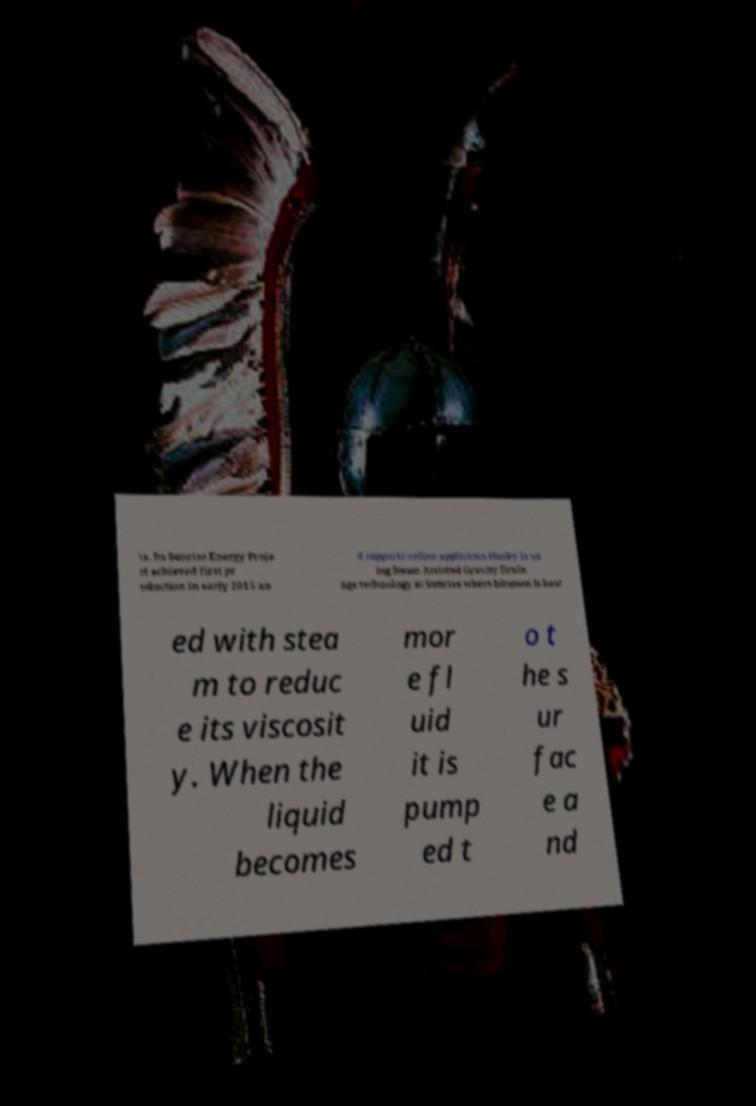I need the written content from this picture converted into text. Can you do that? ta. Its Sunrise Energy Proje ct achieved first pr oduction in early 2015 an d supports online applicants.Husky is us ing Steam Assisted Gravity Drain age technology at Sunrise where bitumen is heat ed with stea m to reduc e its viscosit y. When the liquid becomes mor e fl uid it is pump ed t o t he s ur fac e a nd 